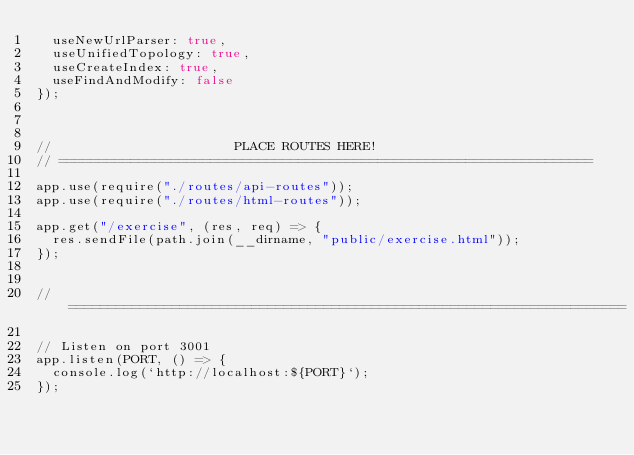<code> <loc_0><loc_0><loc_500><loc_500><_JavaScript_>  useNewUrlParser: true,
  useUnifiedTopology: true,
  useCreateIndex: true,
  useFindAndModify: false
});



//                       PLACE ROUTES HERE!
// ===================================================================

app.use(require("./routes/api-routes"));
app.use(require("./routes/html-routes"));

app.get("/exercise", (res, req) => {
  res.sendFile(path.join(__dirname, "public/exercise.html"));
});


// ======================================================================

// Listen on port 3001
app.listen(PORT, () => {
  console.log(`http://localhost:${PORT}`);
});</code> 